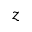<formula> <loc_0><loc_0><loc_500><loc_500>z</formula> 